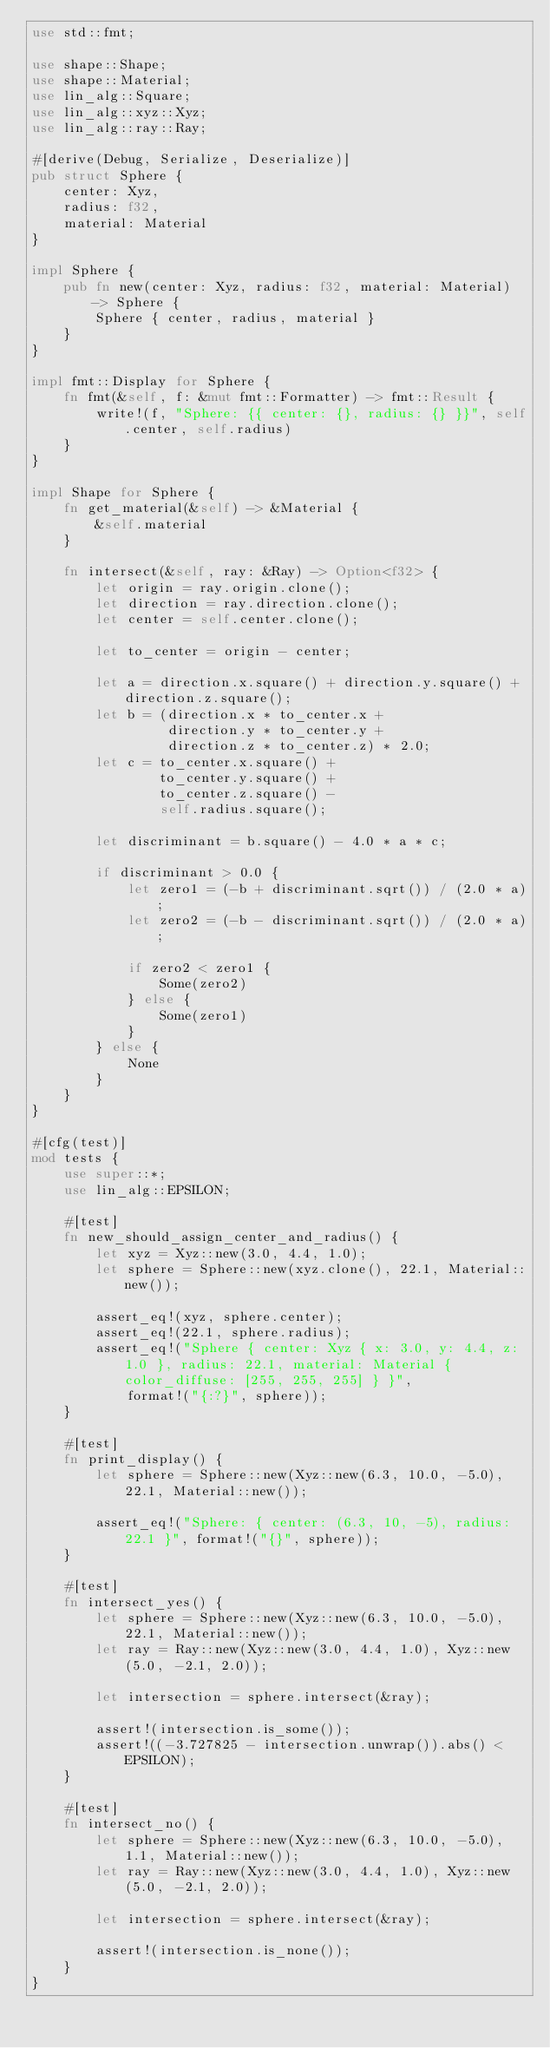Convert code to text. <code><loc_0><loc_0><loc_500><loc_500><_Rust_>use std::fmt;

use shape::Shape;
use shape::Material;
use lin_alg::Square;
use lin_alg::xyz::Xyz;
use lin_alg::ray::Ray;

#[derive(Debug, Serialize, Deserialize)]
pub struct Sphere {
    center: Xyz,
    radius: f32,
    material: Material
}

impl Sphere {
    pub fn new(center: Xyz, radius: f32, material: Material) -> Sphere {
        Sphere { center, radius, material }
    }
}

impl fmt::Display for Sphere {
    fn fmt(&self, f: &mut fmt::Formatter) -> fmt::Result {
        write!(f, "Sphere: {{ center: {}, radius: {} }}", self.center, self.radius)
    }
}

impl Shape for Sphere {
    fn get_material(&self) -> &Material {
        &self.material
    }

    fn intersect(&self, ray: &Ray) -> Option<f32> {
        let origin = ray.origin.clone();
        let direction = ray.direction.clone();
        let center = self.center.clone();

        let to_center = origin - center;

        let a = direction.x.square() + direction.y.square() + direction.z.square();
        let b = (direction.x * to_center.x +
                 direction.y * to_center.y +
                 direction.z * to_center.z) * 2.0;
        let c = to_center.x.square() +
                to_center.y.square() +
                to_center.z.square() -
                self.radius.square();

        let discriminant = b.square() - 4.0 * a * c;

        if discriminant > 0.0 {
            let zero1 = (-b + discriminant.sqrt()) / (2.0 * a);
            let zero2 = (-b - discriminant.sqrt()) / (2.0 * a);

            if zero2 < zero1 {
                Some(zero2)
            } else {
                Some(zero1)
            }
        } else {
            None
        }
    }
}

#[cfg(test)]
mod tests {
    use super::*;
    use lin_alg::EPSILON;

    #[test]
    fn new_should_assign_center_and_radius() {
        let xyz = Xyz::new(3.0, 4.4, 1.0);
        let sphere = Sphere::new(xyz.clone(), 22.1, Material::new());

        assert_eq!(xyz, sphere.center);
        assert_eq!(22.1, sphere.radius);
        assert_eq!("Sphere { center: Xyz { x: 3.0, y: 4.4, z: 1.0 }, radius: 22.1, material: Material { color_diffuse: [255, 255, 255] } }",
            format!("{:?}", sphere));
    }

    #[test]
    fn print_display() {
        let sphere = Sphere::new(Xyz::new(6.3, 10.0, -5.0), 22.1, Material::new());

        assert_eq!("Sphere: { center: (6.3, 10, -5), radius: 22.1 }", format!("{}", sphere));
    }

    #[test]
    fn intersect_yes() {
        let sphere = Sphere::new(Xyz::new(6.3, 10.0, -5.0), 22.1, Material::new());
        let ray = Ray::new(Xyz::new(3.0, 4.4, 1.0), Xyz::new(5.0, -2.1, 2.0));

        let intersection = sphere.intersect(&ray);

        assert!(intersection.is_some());
        assert!((-3.727825 - intersection.unwrap()).abs() < EPSILON);
    }

    #[test]
    fn intersect_no() {
        let sphere = Sphere::new(Xyz::new(6.3, 10.0, -5.0), 1.1, Material::new());
        let ray = Ray::new(Xyz::new(3.0, 4.4, 1.0), Xyz::new(5.0, -2.1, 2.0));

        let intersection = sphere.intersect(&ray);

        assert!(intersection.is_none());
    }
}
</code> 